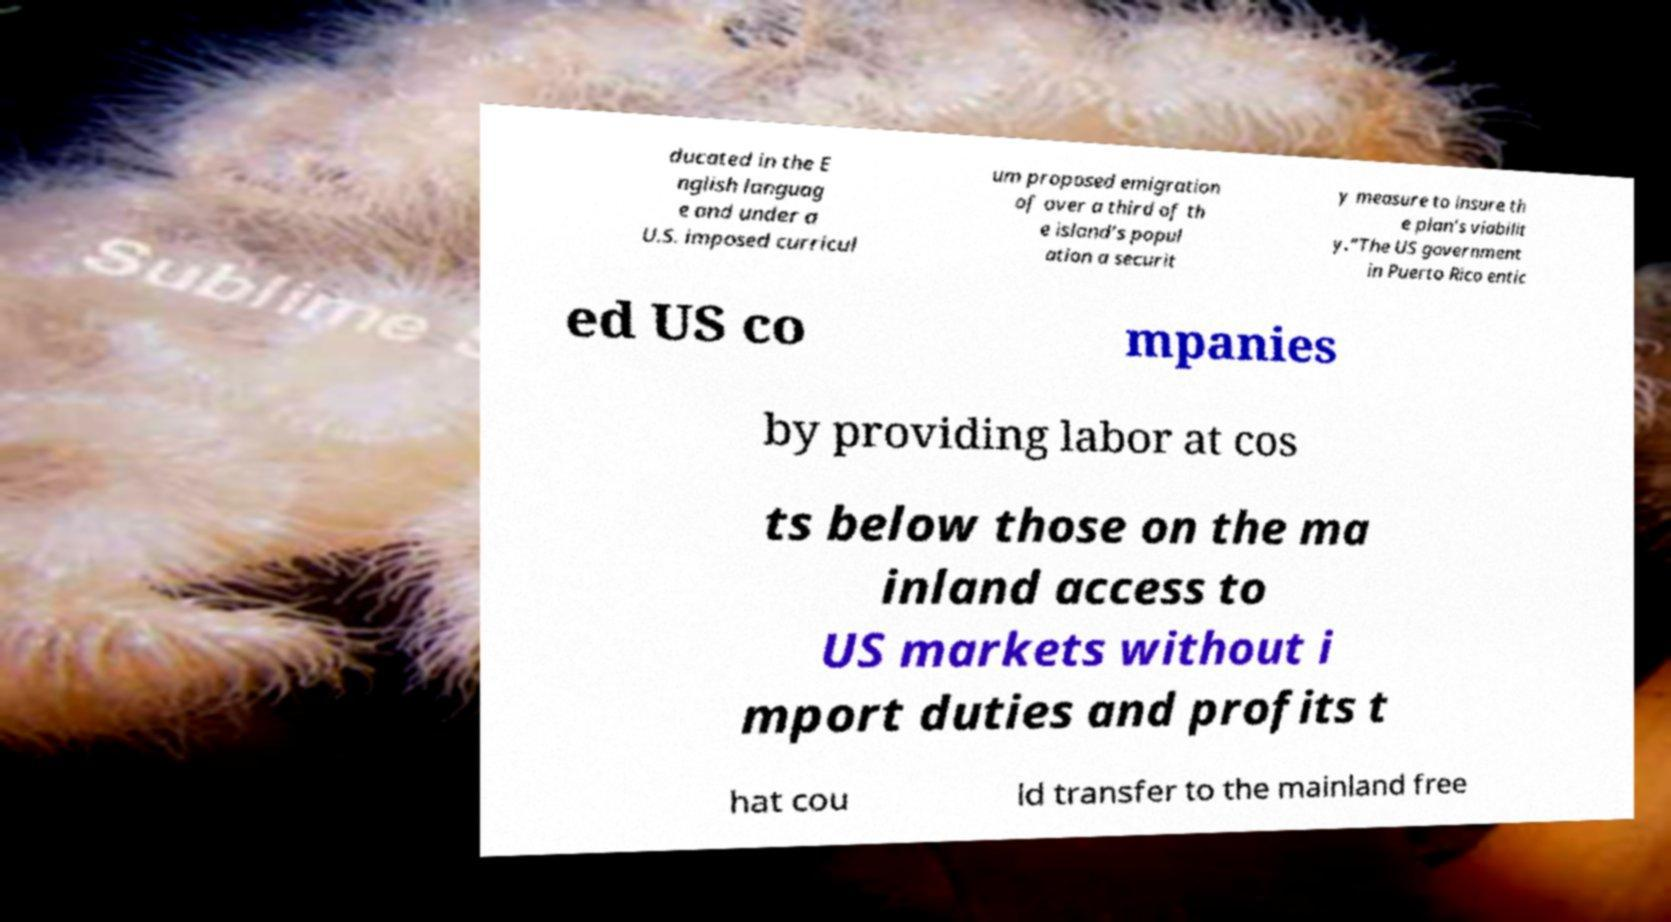Can you read and provide the text displayed in the image?This photo seems to have some interesting text. Can you extract and type it out for me? ducated in the E nglish languag e and under a U.S. imposed curricul um proposed emigration of over a third of th e island’s popul ation a securit y measure to insure th e plan’s viabilit y.”The US government in Puerto Rico entic ed US co mpanies by providing labor at cos ts below those on the ma inland access to US markets without i mport duties and profits t hat cou ld transfer to the mainland free 